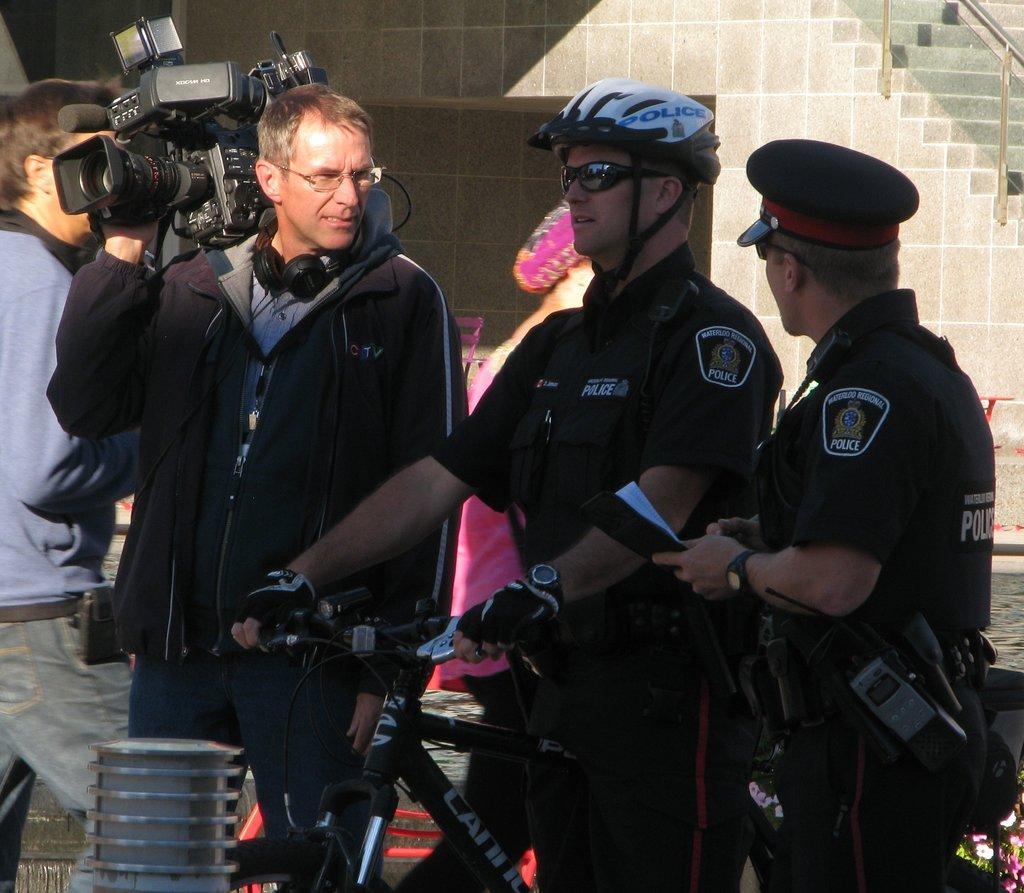In one or two sentences, can you explain what this image depicts? There are four people present as we can see in the middle of this image. The person standing on the right side is wearing a uniform and holding a paper. The person standing in the middle is sitting on a bicycle and the person standing left to him is holding a camera. We can see a wall in the background. 